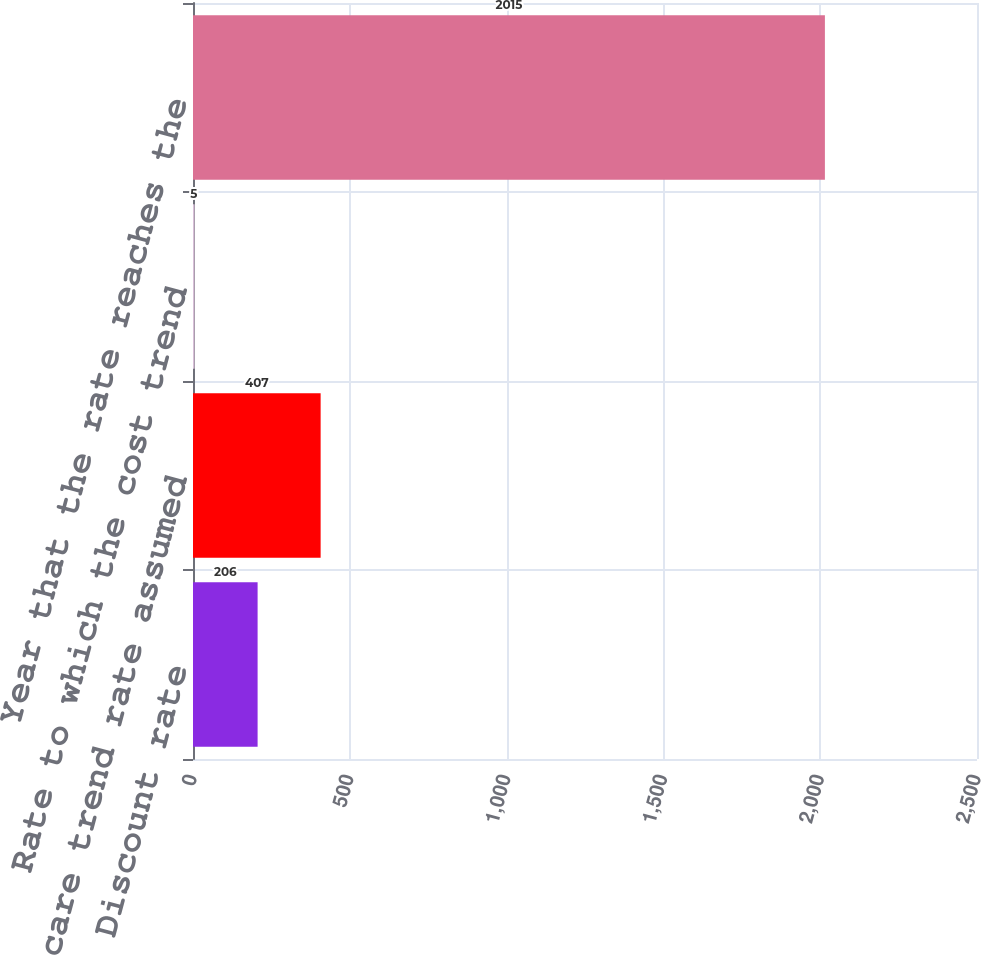Convert chart. <chart><loc_0><loc_0><loc_500><loc_500><bar_chart><fcel>Discount rate<fcel>Health care trend rate assumed<fcel>Rate to which the cost trend<fcel>Year that the rate reaches the<nl><fcel>206<fcel>407<fcel>5<fcel>2015<nl></chart> 